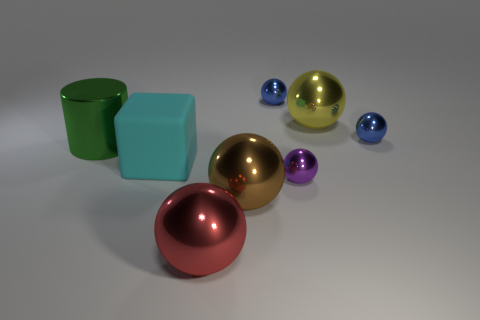Does the large ball left of the large brown shiny ball have the same material as the brown object?
Provide a succinct answer. Yes. How many other things are there of the same material as the big yellow sphere?
Make the answer very short. 6. How many objects are either blue spheres that are on the right side of the small purple thing or things in front of the large green cylinder?
Offer a terse response. 5. There is a tiny object that is in front of the large green cylinder; is it the same shape as the blue metal object that is on the right side of the purple metal sphere?
Make the answer very short. Yes. There is a red metal thing that is the same size as the cylinder; what is its shape?
Offer a terse response. Sphere. What number of rubber things are cyan objects or large brown cubes?
Your response must be concise. 1. Do the big object behind the big green shiny cylinder and the cyan object left of the tiny purple shiny ball have the same material?
Provide a short and direct response. No. Are there more shiny things that are in front of the matte block than big metallic things behind the cylinder?
Keep it short and to the point. Yes. Are any large cyan metallic blocks visible?
Your answer should be very brief. No. How many things are tiny yellow cubes or big green objects?
Provide a succinct answer. 1. 